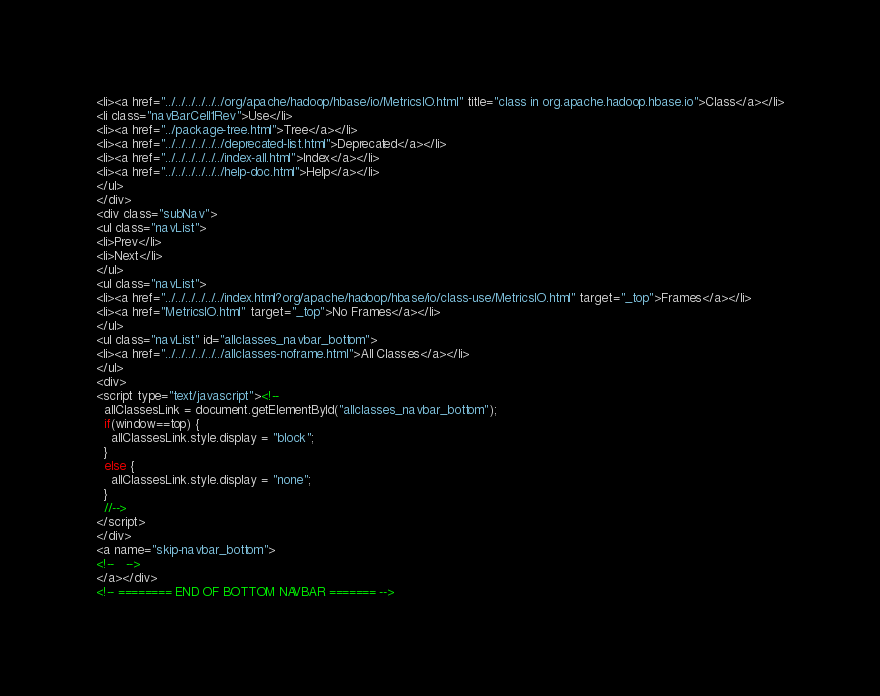Convert code to text. <code><loc_0><loc_0><loc_500><loc_500><_HTML_><li><a href="../../../../../../org/apache/hadoop/hbase/io/MetricsIO.html" title="class in org.apache.hadoop.hbase.io">Class</a></li>
<li class="navBarCell1Rev">Use</li>
<li><a href="../package-tree.html">Tree</a></li>
<li><a href="../../../../../../deprecated-list.html">Deprecated</a></li>
<li><a href="../../../../../../index-all.html">Index</a></li>
<li><a href="../../../../../../help-doc.html">Help</a></li>
</ul>
</div>
<div class="subNav">
<ul class="navList">
<li>Prev</li>
<li>Next</li>
</ul>
<ul class="navList">
<li><a href="../../../../../../index.html?org/apache/hadoop/hbase/io/class-use/MetricsIO.html" target="_top">Frames</a></li>
<li><a href="MetricsIO.html" target="_top">No Frames</a></li>
</ul>
<ul class="navList" id="allclasses_navbar_bottom">
<li><a href="../../../../../../allclasses-noframe.html">All Classes</a></li>
</ul>
<div>
<script type="text/javascript"><!--
  allClassesLink = document.getElementById("allclasses_navbar_bottom");
  if(window==top) {
    allClassesLink.style.display = "block";
  }
  else {
    allClassesLink.style.display = "none";
  }
  //-->
</script>
</div>
<a name="skip-navbar_bottom">
<!--   -->
</a></div>
<!-- ======== END OF BOTTOM NAVBAR ======= --></code> 